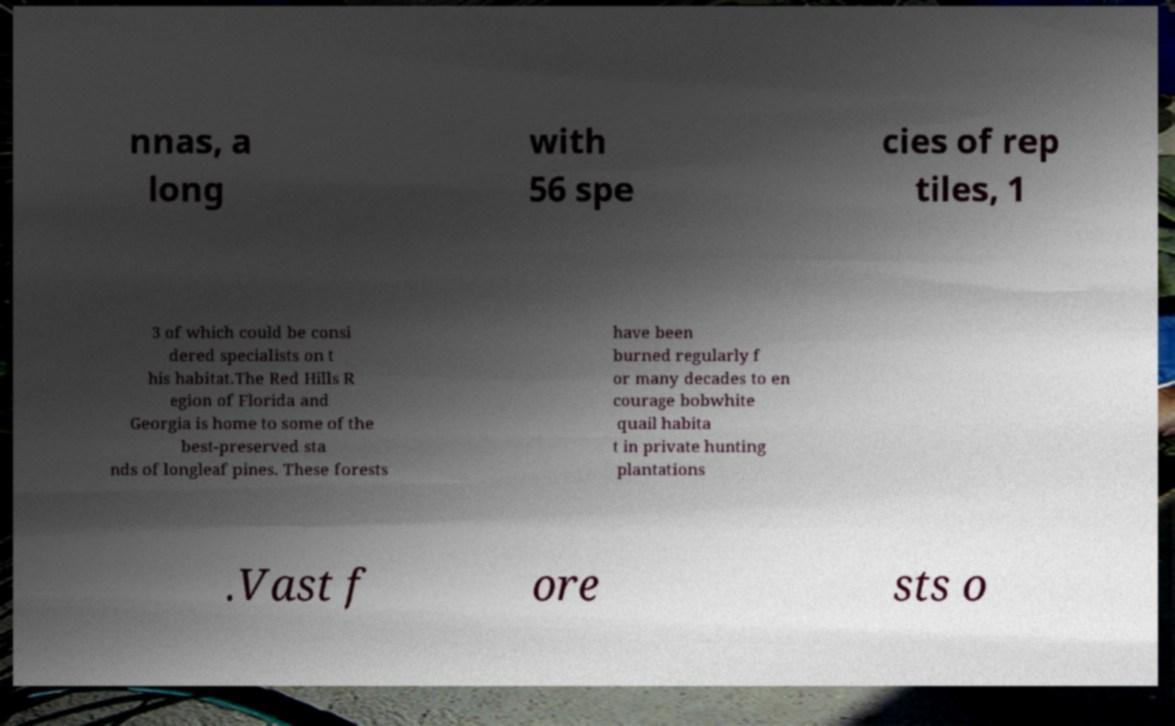For documentation purposes, I need the text within this image transcribed. Could you provide that? nnas, a long with 56 spe cies of rep tiles, 1 3 of which could be consi dered specialists on t his habitat.The Red Hills R egion of Florida and Georgia is home to some of the best-preserved sta nds of longleaf pines. These forests have been burned regularly f or many decades to en courage bobwhite quail habita t in private hunting plantations .Vast f ore sts o 